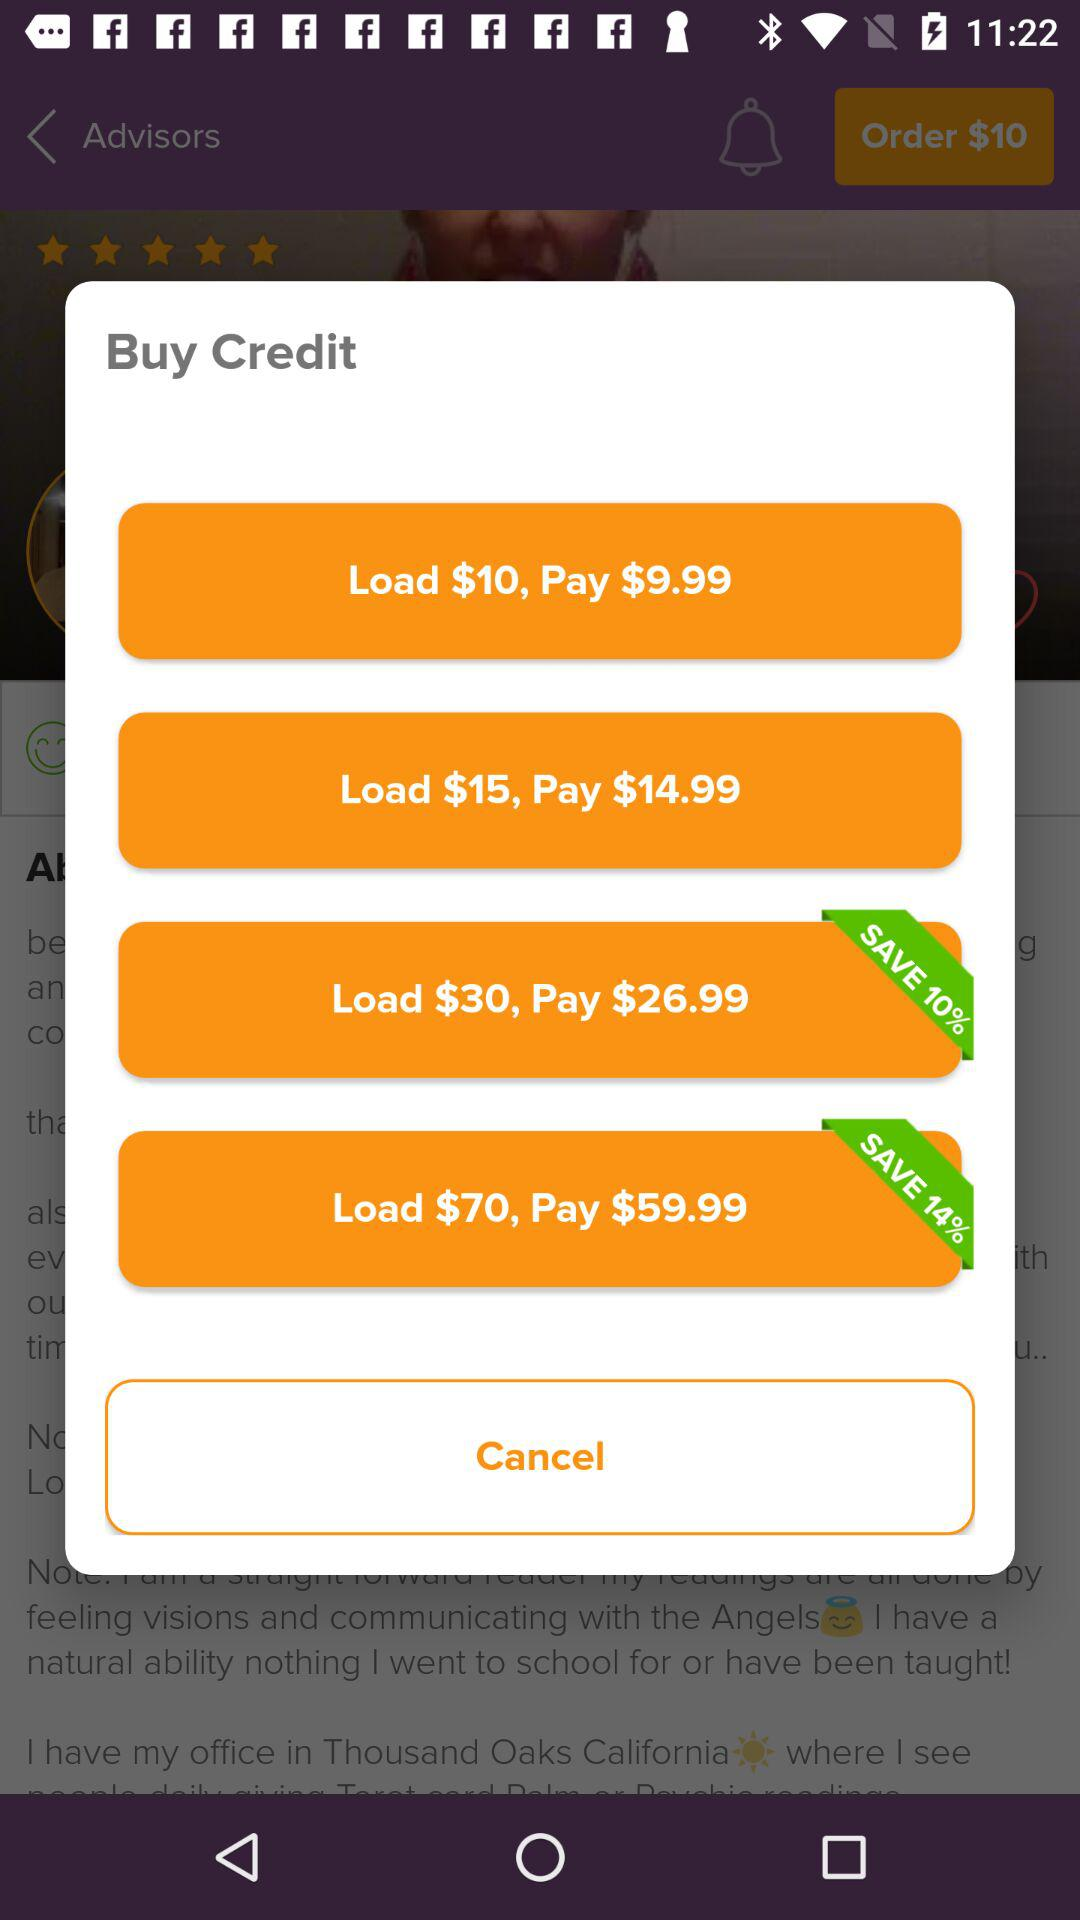How much more does it cost to load $15 than $10?
Answer the question using a single word or phrase. $5 